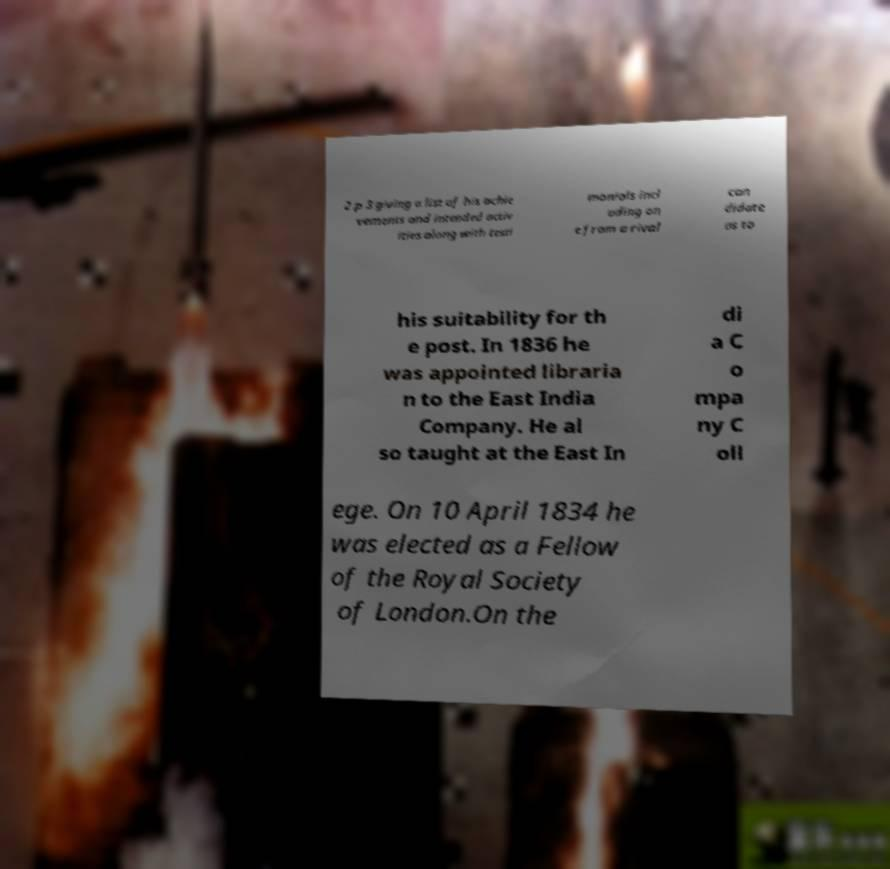Can you accurately transcribe the text from the provided image for me? 2 p 3 giving a list of his achie vements and intended activ ities along with testi monials incl uding on e from a rival can didate as to his suitability for th e post. In 1836 he was appointed libraria n to the East India Company. He al so taught at the East In di a C o mpa ny C oll ege. On 10 April 1834 he was elected as a Fellow of the Royal Society of London.On the 